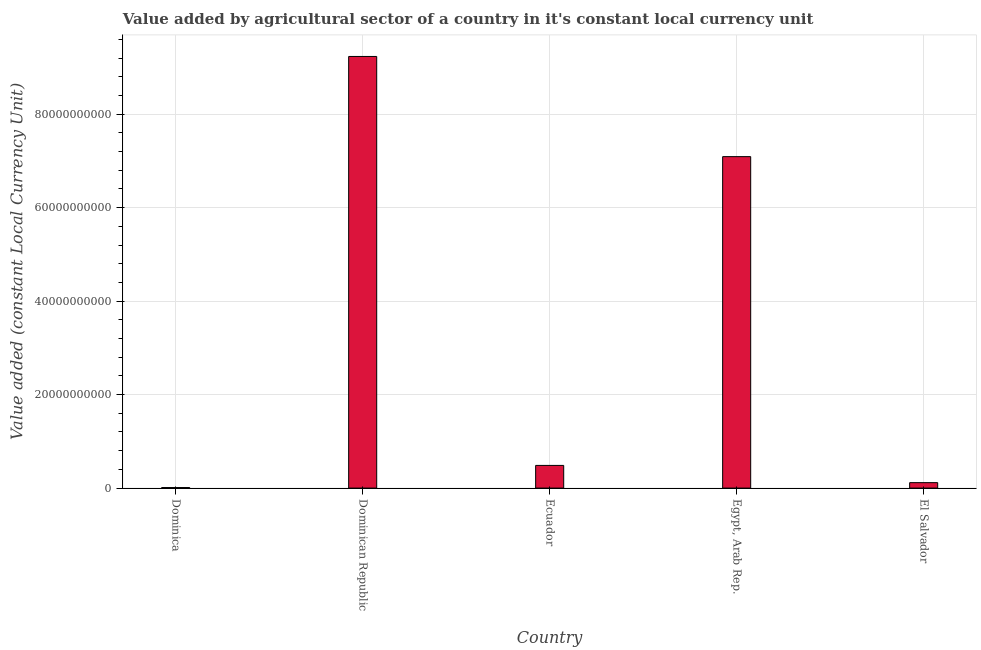What is the title of the graph?
Give a very brief answer. Value added by agricultural sector of a country in it's constant local currency unit. What is the label or title of the X-axis?
Give a very brief answer. Country. What is the label or title of the Y-axis?
Offer a terse response. Value added (constant Local Currency Unit). What is the value added by agriculture sector in El Salvador?
Your response must be concise. 1.16e+09. Across all countries, what is the maximum value added by agriculture sector?
Provide a short and direct response. 9.23e+1. Across all countries, what is the minimum value added by agriculture sector?
Offer a terse response. 1.16e+08. In which country was the value added by agriculture sector maximum?
Offer a very short reply. Dominican Republic. In which country was the value added by agriculture sector minimum?
Provide a short and direct response. Dominica. What is the sum of the value added by agriculture sector?
Make the answer very short. 1.69e+11. What is the difference between the value added by agriculture sector in Dominica and El Salvador?
Provide a short and direct response. -1.05e+09. What is the average value added by agriculture sector per country?
Offer a terse response. 3.39e+1. What is the median value added by agriculture sector?
Make the answer very short. 4.85e+09. Is the value added by agriculture sector in Dominican Republic less than that in El Salvador?
Ensure brevity in your answer.  No. What is the difference between the highest and the second highest value added by agriculture sector?
Your answer should be compact. 2.14e+1. What is the difference between the highest and the lowest value added by agriculture sector?
Offer a very short reply. 9.22e+1. In how many countries, is the value added by agriculture sector greater than the average value added by agriculture sector taken over all countries?
Offer a very short reply. 2. How many countries are there in the graph?
Provide a short and direct response. 5. What is the difference between two consecutive major ticks on the Y-axis?
Give a very brief answer. 2.00e+1. Are the values on the major ticks of Y-axis written in scientific E-notation?
Give a very brief answer. No. What is the Value added (constant Local Currency Unit) in Dominica?
Your response must be concise. 1.16e+08. What is the Value added (constant Local Currency Unit) in Dominican Republic?
Provide a succinct answer. 9.23e+1. What is the Value added (constant Local Currency Unit) of Ecuador?
Your answer should be compact. 4.85e+09. What is the Value added (constant Local Currency Unit) of Egypt, Arab Rep.?
Your response must be concise. 7.09e+1. What is the Value added (constant Local Currency Unit) of El Salvador?
Provide a succinct answer. 1.16e+09. What is the difference between the Value added (constant Local Currency Unit) in Dominica and Dominican Republic?
Offer a terse response. -9.22e+1. What is the difference between the Value added (constant Local Currency Unit) in Dominica and Ecuador?
Your response must be concise. -4.74e+09. What is the difference between the Value added (constant Local Currency Unit) in Dominica and Egypt, Arab Rep.?
Provide a succinct answer. -7.08e+1. What is the difference between the Value added (constant Local Currency Unit) in Dominica and El Salvador?
Your answer should be very brief. -1.05e+09. What is the difference between the Value added (constant Local Currency Unit) in Dominican Republic and Ecuador?
Offer a terse response. 8.75e+1. What is the difference between the Value added (constant Local Currency Unit) in Dominican Republic and Egypt, Arab Rep.?
Make the answer very short. 2.14e+1. What is the difference between the Value added (constant Local Currency Unit) in Dominican Republic and El Salvador?
Your answer should be very brief. 9.12e+1. What is the difference between the Value added (constant Local Currency Unit) in Ecuador and Egypt, Arab Rep.?
Keep it short and to the point. -6.61e+1. What is the difference between the Value added (constant Local Currency Unit) in Ecuador and El Salvador?
Make the answer very short. 3.69e+09. What is the difference between the Value added (constant Local Currency Unit) in Egypt, Arab Rep. and El Salvador?
Keep it short and to the point. 6.97e+1. What is the ratio of the Value added (constant Local Currency Unit) in Dominica to that in Ecuador?
Your answer should be very brief. 0.02. What is the ratio of the Value added (constant Local Currency Unit) in Dominica to that in Egypt, Arab Rep.?
Keep it short and to the point. 0. What is the ratio of the Value added (constant Local Currency Unit) in Dominica to that in El Salvador?
Provide a short and direct response. 0.1. What is the ratio of the Value added (constant Local Currency Unit) in Dominican Republic to that in Ecuador?
Your response must be concise. 19.03. What is the ratio of the Value added (constant Local Currency Unit) in Dominican Republic to that in Egypt, Arab Rep.?
Keep it short and to the point. 1.3. What is the ratio of the Value added (constant Local Currency Unit) in Dominican Republic to that in El Salvador?
Your answer should be compact. 79.33. What is the ratio of the Value added (constant Local Currency Unit) in Ecuador to that in Egypt, Arab Rep.?
Keep it short and to the point. 0.07. What is the ratio of the Value added (constant Local Currency Unit) in Ecuador to that in El Salvador?
Your answer should be compact. 4.17. What is the ratio of the Value added (constant Local Currency Unit) in Egypt, Arab Rep. to that in El Salvador?
Provide a succinct answer. 60.92. 